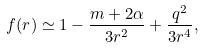<formula> <loc_0><loc_0><loc_500><loc_500>f ( r ) \simeq 1 - \frac { m + 2 \alpha } { 3 r ^ { 2 } } + \frac { q ^ { 2 } } { 3 r ^ { 4 } } ,</formula> 